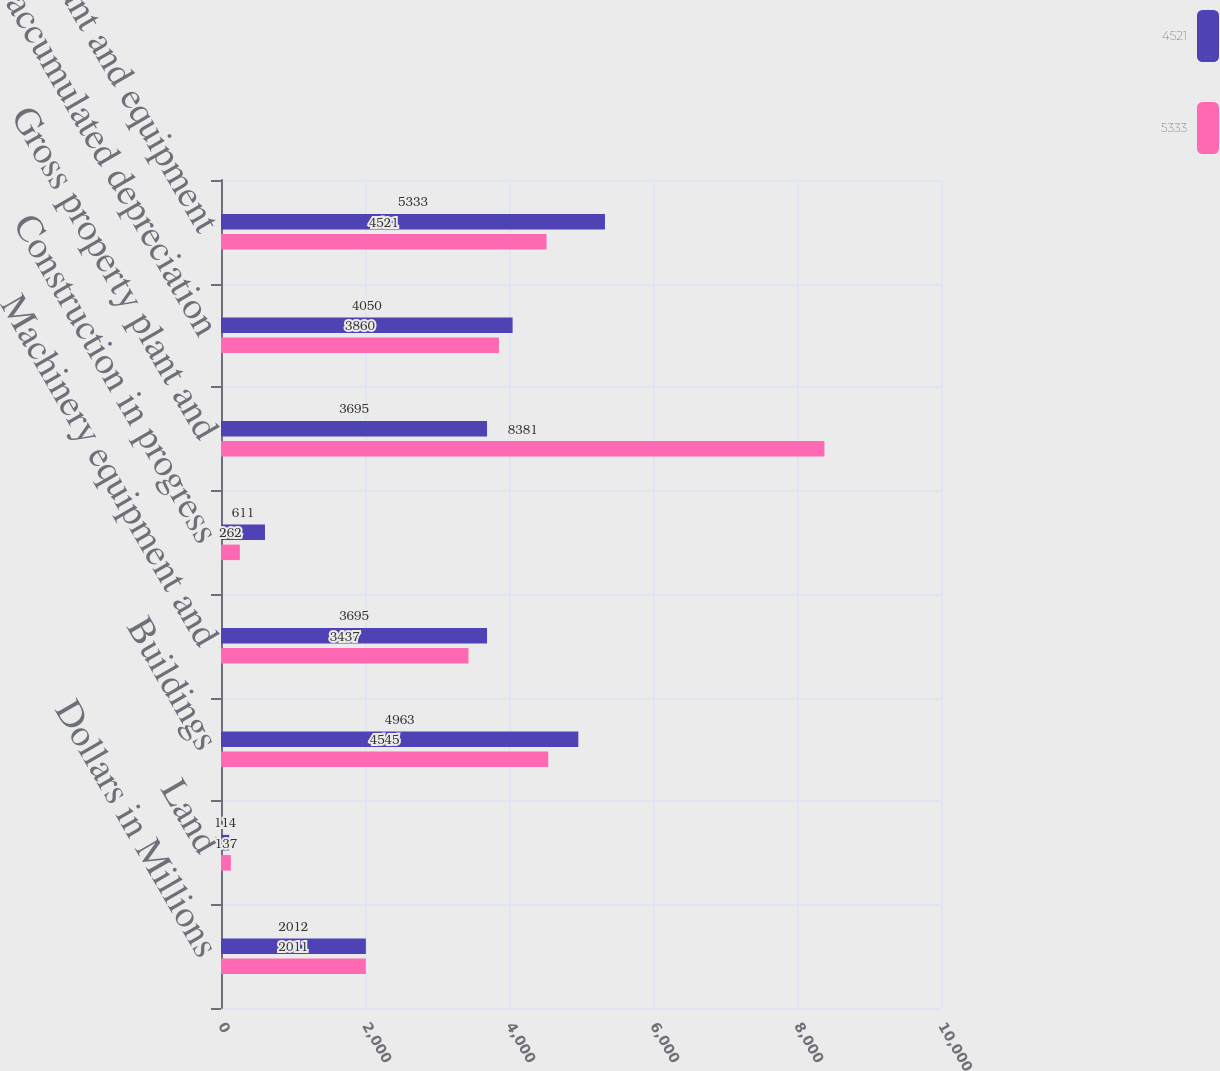Convert chart. <chart><loc_0><loc_0><loc_500><loc_500><stacked_bar_chart><ecel><fcel>Dollars in Millions<fcel>Land<fcel>Buildings<fcel>Machinery equipment and<fcel>Construction in progress<fcel>Gross property plant and<fcel>Less accumulated depreciation<fcel>Property plant and equipment<nl><fcel>4521<fcel>2012<fcel>114<fcel>4963<fcel>3695<fcel>611<fcel>3695<fcel>4050<fcel>5333<nl><fcel>5333<fcel>2011<fcel>137<fcel>4545<fcel>3437<fcel>262<fcel>8381<fcel>3860<fcel>4521<nl></chart> 